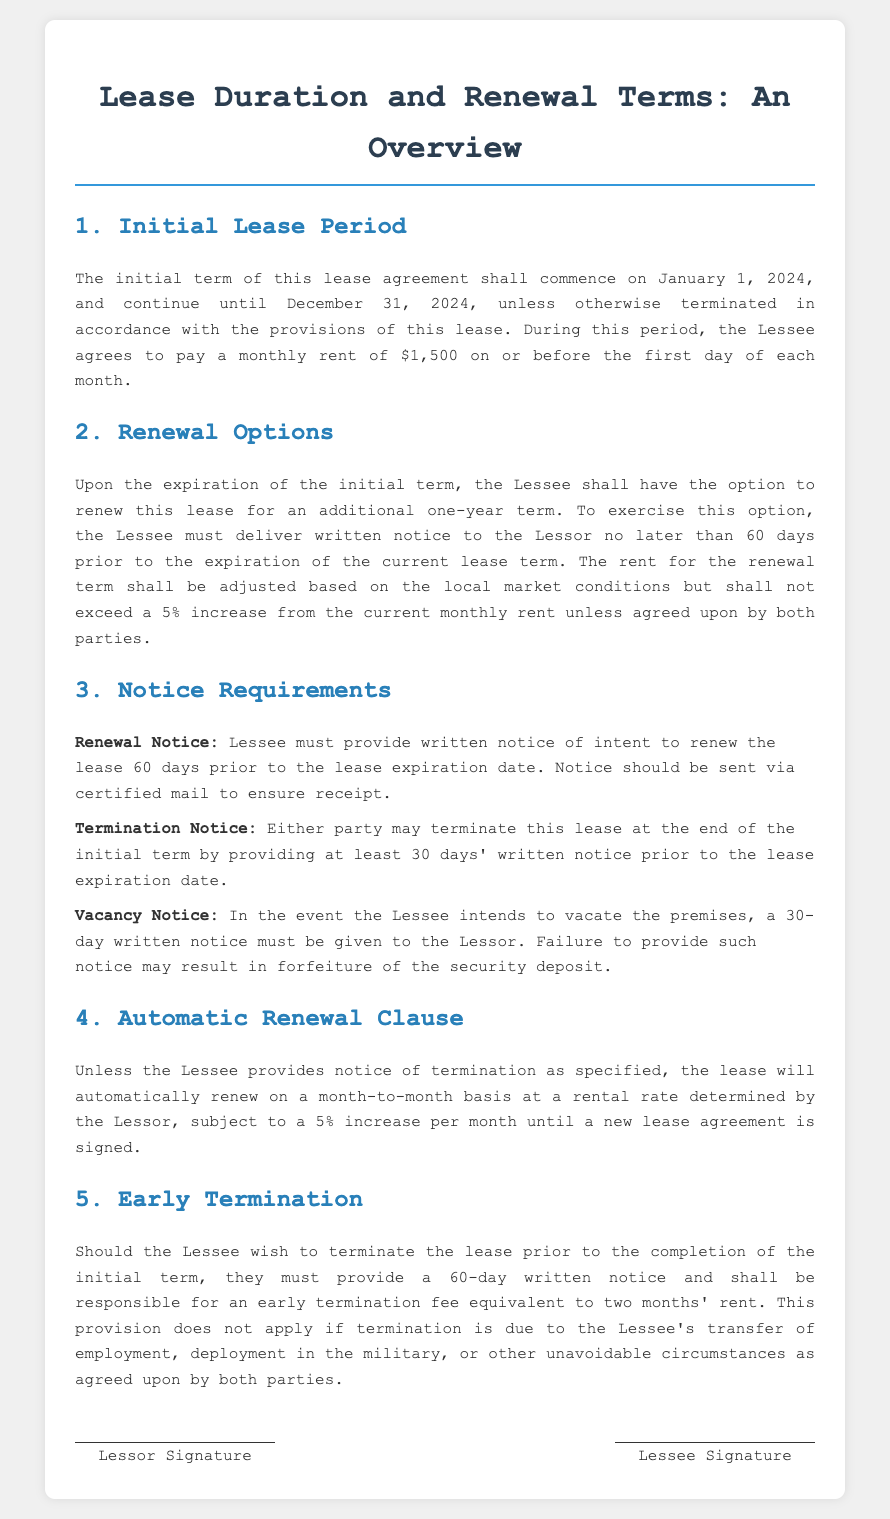What is the initial lease period? The initial lease period is defined as the time from January 1, 2024, to December 31, 2024.
Answer: January 1, 2024, to December 31, 2024 How much is the monthly rent? The document specifies that the monthly rent during the initial lease period is $1,500.
Answer: $1,500 How many days' notice is required to renew the lease? The document states that the Lessee must deliver written notice to the Lessor no later than 60 days prior to the expiration of the current lease term.
Answer: 60 days What is the maximum allowable rent increase for the renewal term? The renewal term rent increase is capped based on local market conditions but shall not exceed a 5% increase from the current monthly rent unless agreed upon.
Answer: 5% What is the early termination notice period? The document indicates that the Lessee must provide a 60-day written notice for early termination.
Answer: 60 days What is the penalty for providing inadequate notice when vacating? The document states that failure to provide a 30-day notice may result in forfeiture of the security deposit.
Answer: Forfeiture of the security deposit What happens if the Lessee does not provide notice of termination? If the Lessee does not provide notice of termination, the lease will automatically renew on a month-to-month basis, subject to conditions.
Answer: Automatically renew What is the early termination fee? The early termination fee is equivalent to two months' rent as specified in the document.
Answer: Two months' rent 